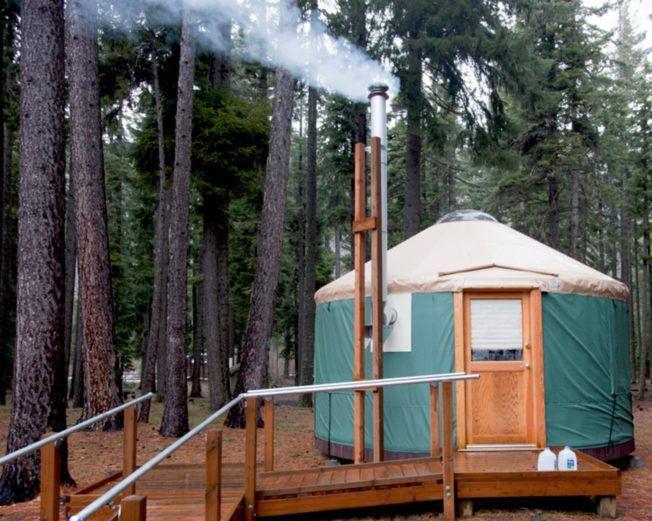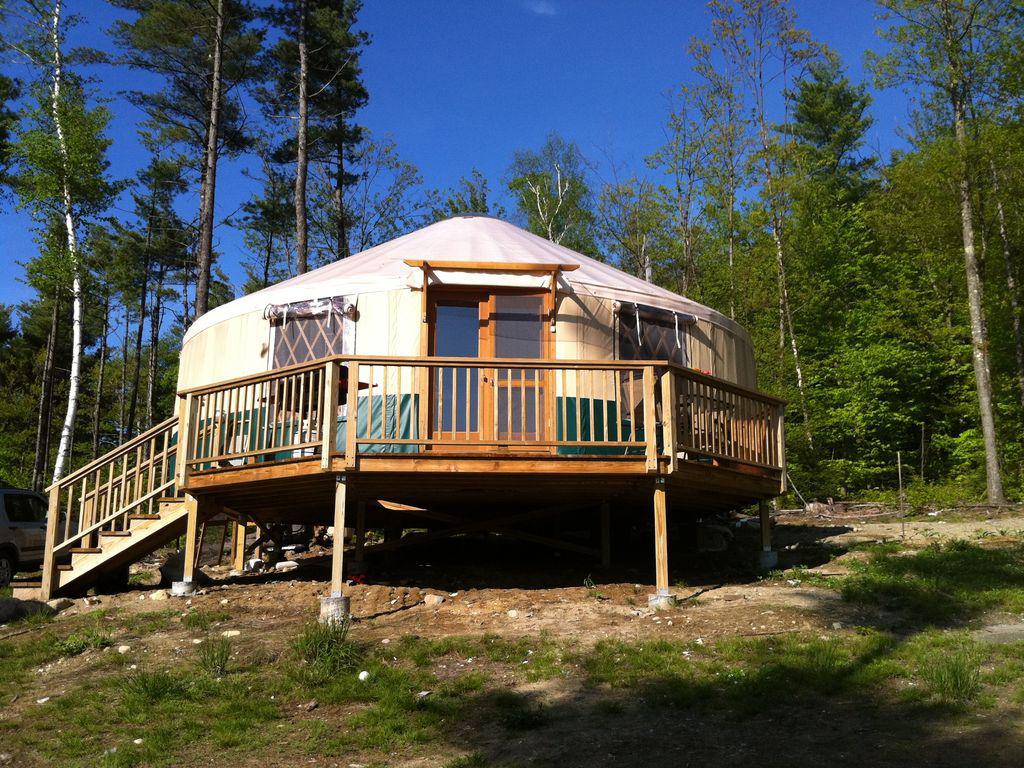The first image is the image on the left, the second image is the image on the right. Assess this claim about the two images: "In one image, a yurt with similar colored walls and ceiling with a dark rim where the roof connects, has a door, but no windows.". Correct or not? Answer yes or no. No. 